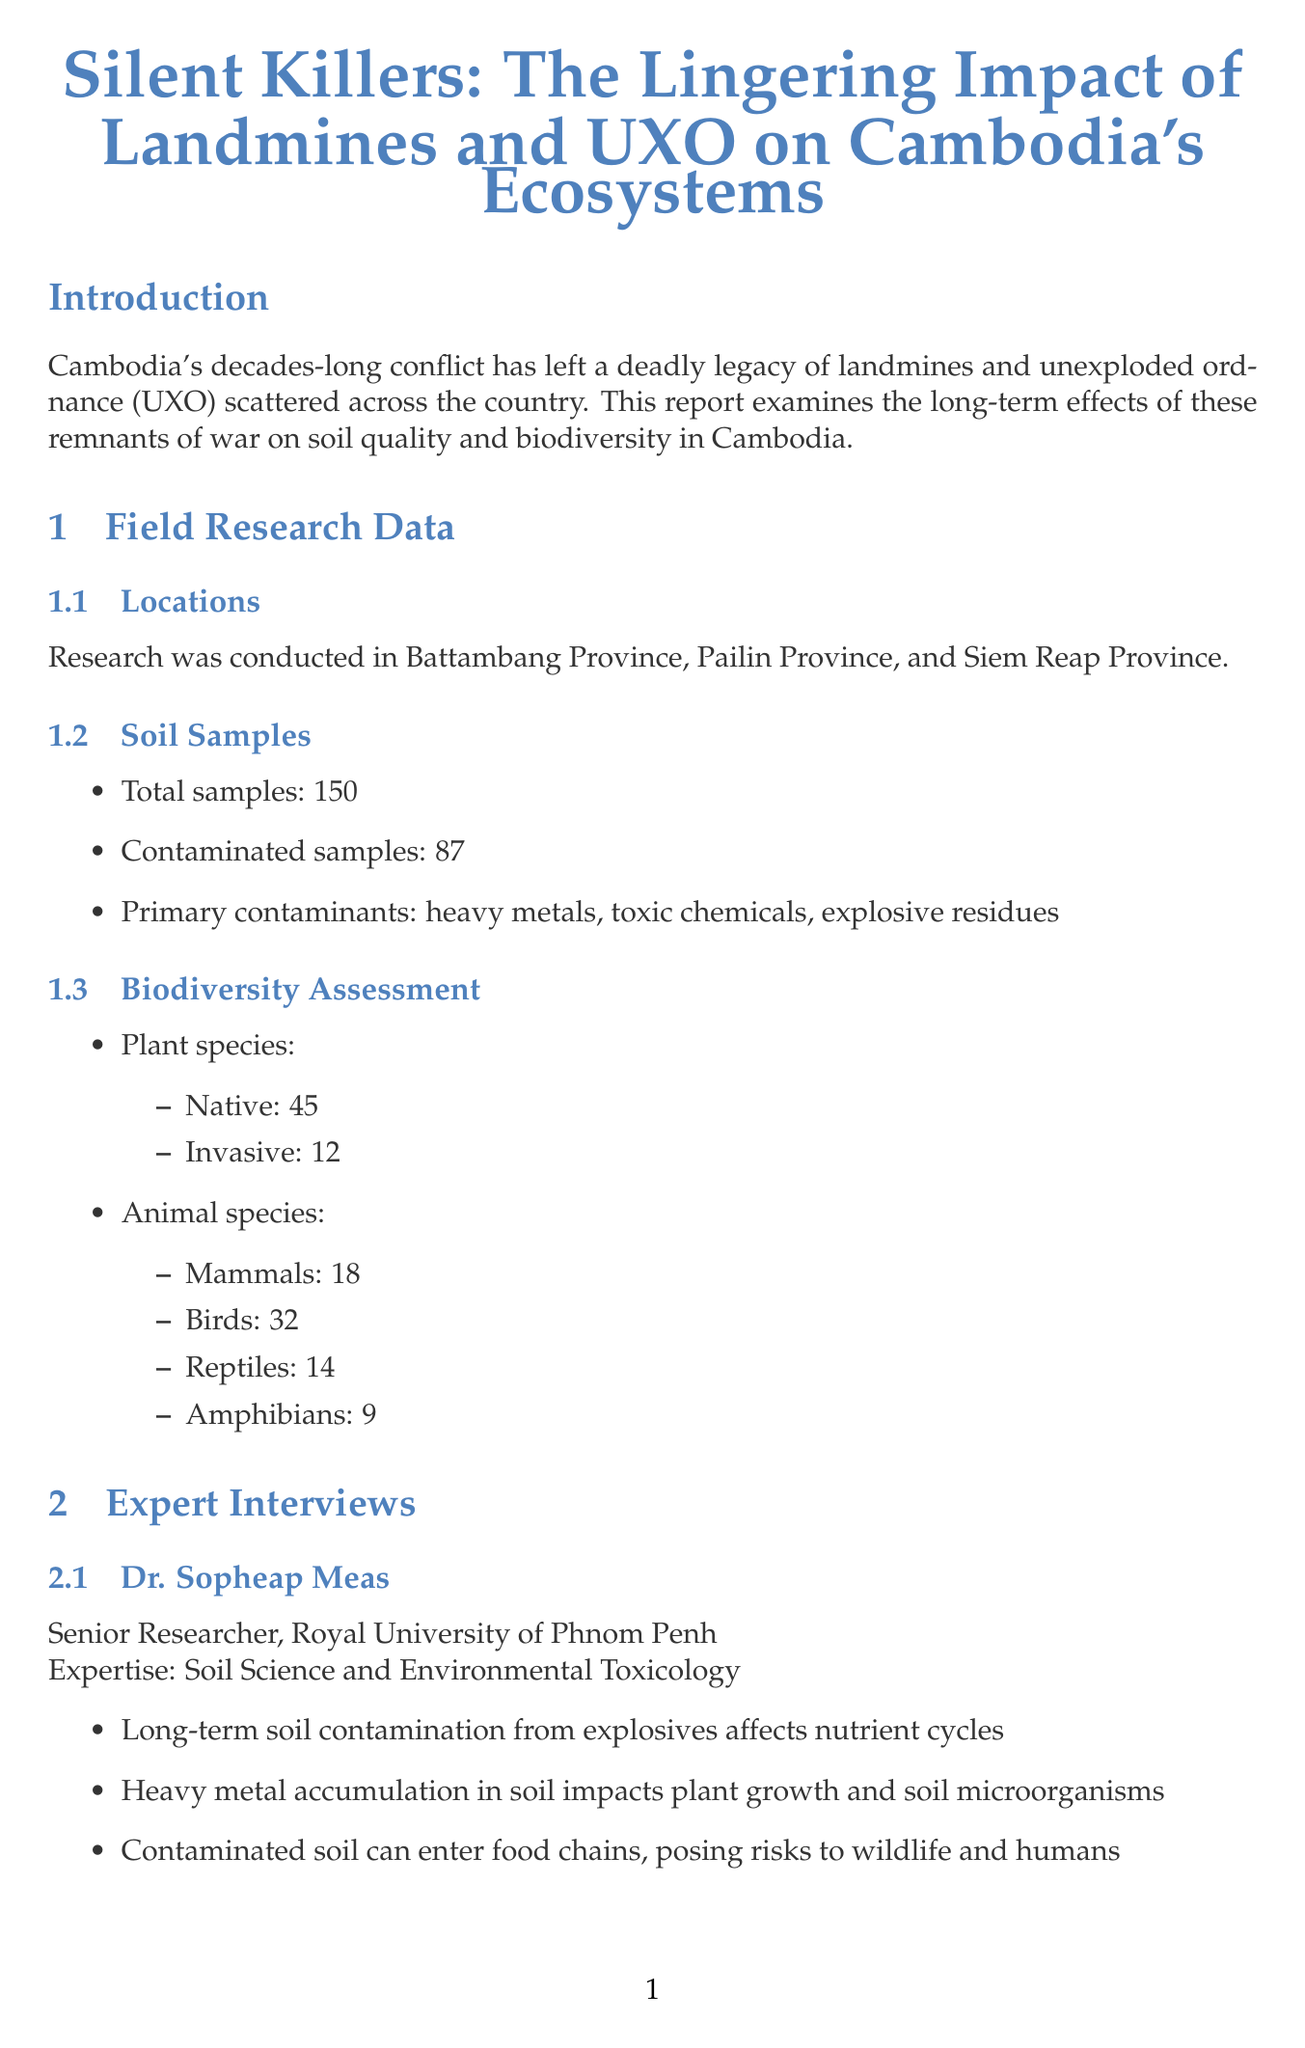what is the report title? The report title is prominently displayed at the beginning of the document.
Answer: Silent Killers: The Lingering Impact of Landmines and UXO on Cambodia's Ecosystems how many total soil samples were taken? The total number of soil samples is specified in the field research data section of the document.
Answer: 150 who is the Program Manager at the Cambodian Mine Action Centre? The name and title of the Program Manager are provided in the expert interviews section.
Answer: Vannak Sou what percentage of soil samples were contaminated? The percentage can be calculated from the total number and the contaminated samples provided in the document.
Answer: 58% which province had its focus assessed for biodiversity related to UXO? One of the provinces listed is the focus of the case studies involving biodiversity.
Answer: Tonle Sap Lake Region what are the primary contaminants found in the soil? The document lists several contaminants in the soil samples analyzed.
Answer: heavy metals, toxic chemicals, explosive residues how many native plant species were identified? The document provides a count of native plant species in the biodiversity assessment section.
Answer: 45 what are the key findings related to forest regeneration in the Cardamom Mountains? The findings related to forest regeneration challenges are included in the case studies section.
Answer: Stunted forest regeneration in heavily contaminated areas which expert discussed "accidental wildlife sanctuaries"? The expert's insights include aspects related to wildlife sanctuaries created due to landmines and UXO.
Answer: Dr. Emma Thompson 